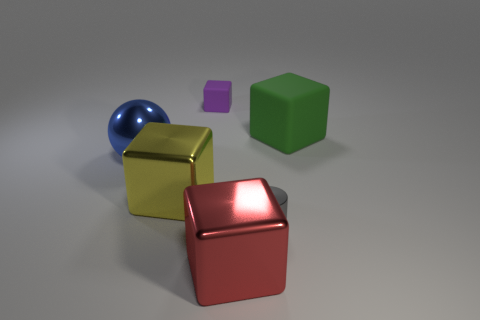Subtract all large red cubes. How many cubes are left? 3 Add 3 big matte cubes. How many objects exist? 9 Subtract 3 blocks. How many blocks are left? 1 Subtract all spheres. How many objects are left? 5 Subtract all purple blocks. How many blocks are left? 3 Subtract all yellow cubes. Subtract all blue cylinders. How many cubes are left? 3 Subtract all red cylinders. How many yellow cubes are left? 1 Subtract all cyan things. Subtract all green things. How many objects are left? 5 Add 6 blue shiny objects. How many blue shiny objects are left? 7 Add 1 large red metal cubes. How many large red metal cubes exist? 2 